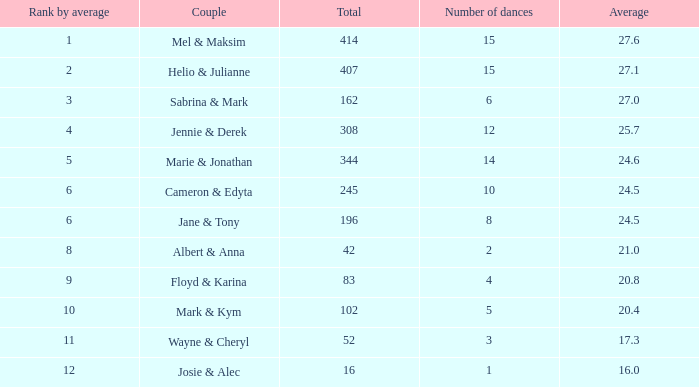What is the average place for a couple with the rank by average of 9 and total smaller than 83? None. 